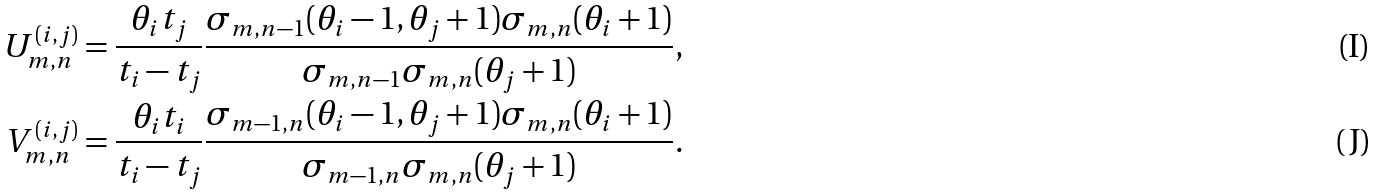<formula> <loc_0><loc_0><loc_500><loc_500>U _ { m , n } ^ { ( i , j ) } & = \frac { \theta _ { i } t _ { j } } { t _ { i } - t _ { j } } \frac { \sigma _ { m , n - 1 } ( \theta _ { i } - 1 , \theta _ { j } + 1 ) \sigma _ { m , n } ( \theta _ { i } + 1 ) } { \sigma _ { m , n - 1 } \sigma _ { m , n } ( \theta _ { j } + 1 ) } , \\ V _ { m , n } ^ { ( i , j ) } & = \frac { \theta _ { i } t _ { i } } { t _ { i } - t _ { j } } \frac { \sigma _ { m - 1 , n } ( \theta _ { i } - 1 , \theta _ { j } + 1 ) \sigma _ { m , n } ( \theta _ { i } + 1 ) } { \sigma _ { m - 1 , n } \sigma _ { m , n } ( \theta _ { j } + 1 ) } .</formula> 